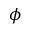Convert formula to latex. <formula><loc_0><loc_0><loc_500><loc_500>\phi</formula> 